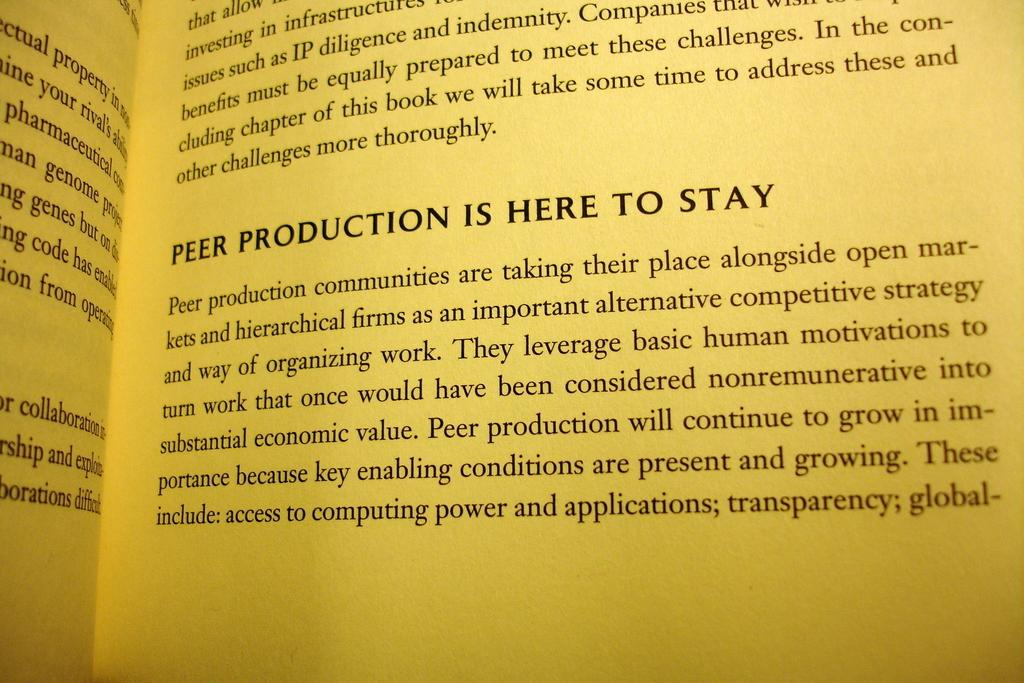<image>
Write a terse but informative summary of the picture. A book is opened to a page talking about peer production. 